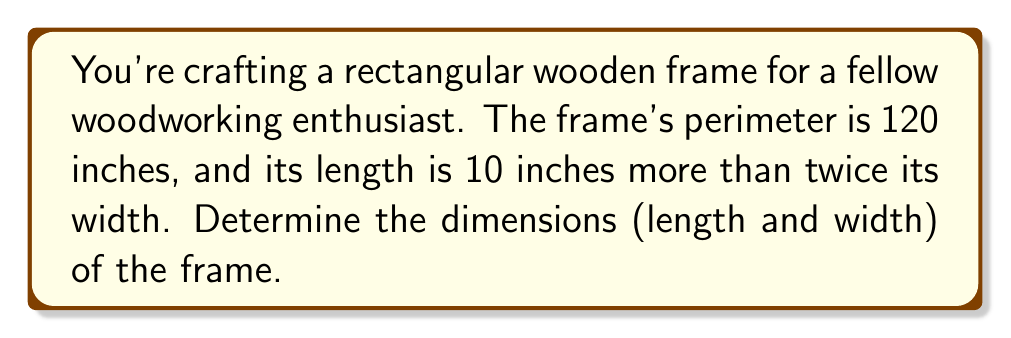Can you solve this math problem? Let's approach this step-by-step:

1) Let $w$ represent the width of the frame.
2) The length is 10 inches more than twice the width, so we can express it as $2w + 10$.

3) The perimeter of a rectangle is given by the formula:
   $$P = 2l + 2w$$
   where $P$ is the perimeter, $l$ is the length, and $w$ is the width.

4) We know the perimeter is 120 inches, so we can set up the equation:
   $$120 = 2(2w + 10) + 2w$$

5) Simplify the right side of the equation:
   $$120 = 4w + 20 + 2w = 6w + 20$$

6) Subtract 20 from both sides:
   $$100 = 6w$$

7) Divide both sides by 6:
   $$\frac{100}{6} = w$$
   $$w = \frac{50}{3} \approx 16.67$$

8) The width is approximately 16.67 inches.

9) To find the length, we use $2w + 10$:
   $$l = 2(\frac{50}{3}) + 10 = \frac{100}{3} + 10 = \frac{130}{3} \approx 43.33$$

10) The length is approximately 43.33 inches.

Therefore, the dimensions of the frame are approximately 16.67 inches by 43.33 inches.
Answer: Width: $\frac{50}{3}$ inches, Length: $\frac{130}{3}$ inches 